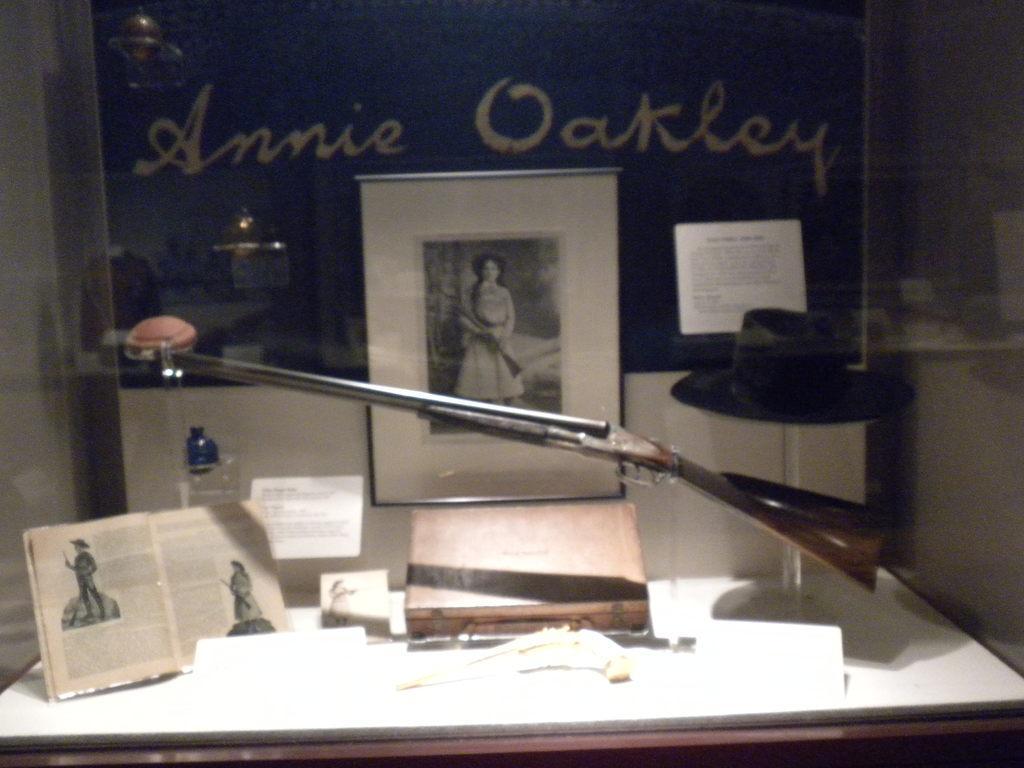Please provide a concise description of this image. In this picture there is a frame and there is a book and hat and gun and there are boards and objects on the table. In the foreground there is a glass and there is reflection of objects on the glass. At the back there is a text. 